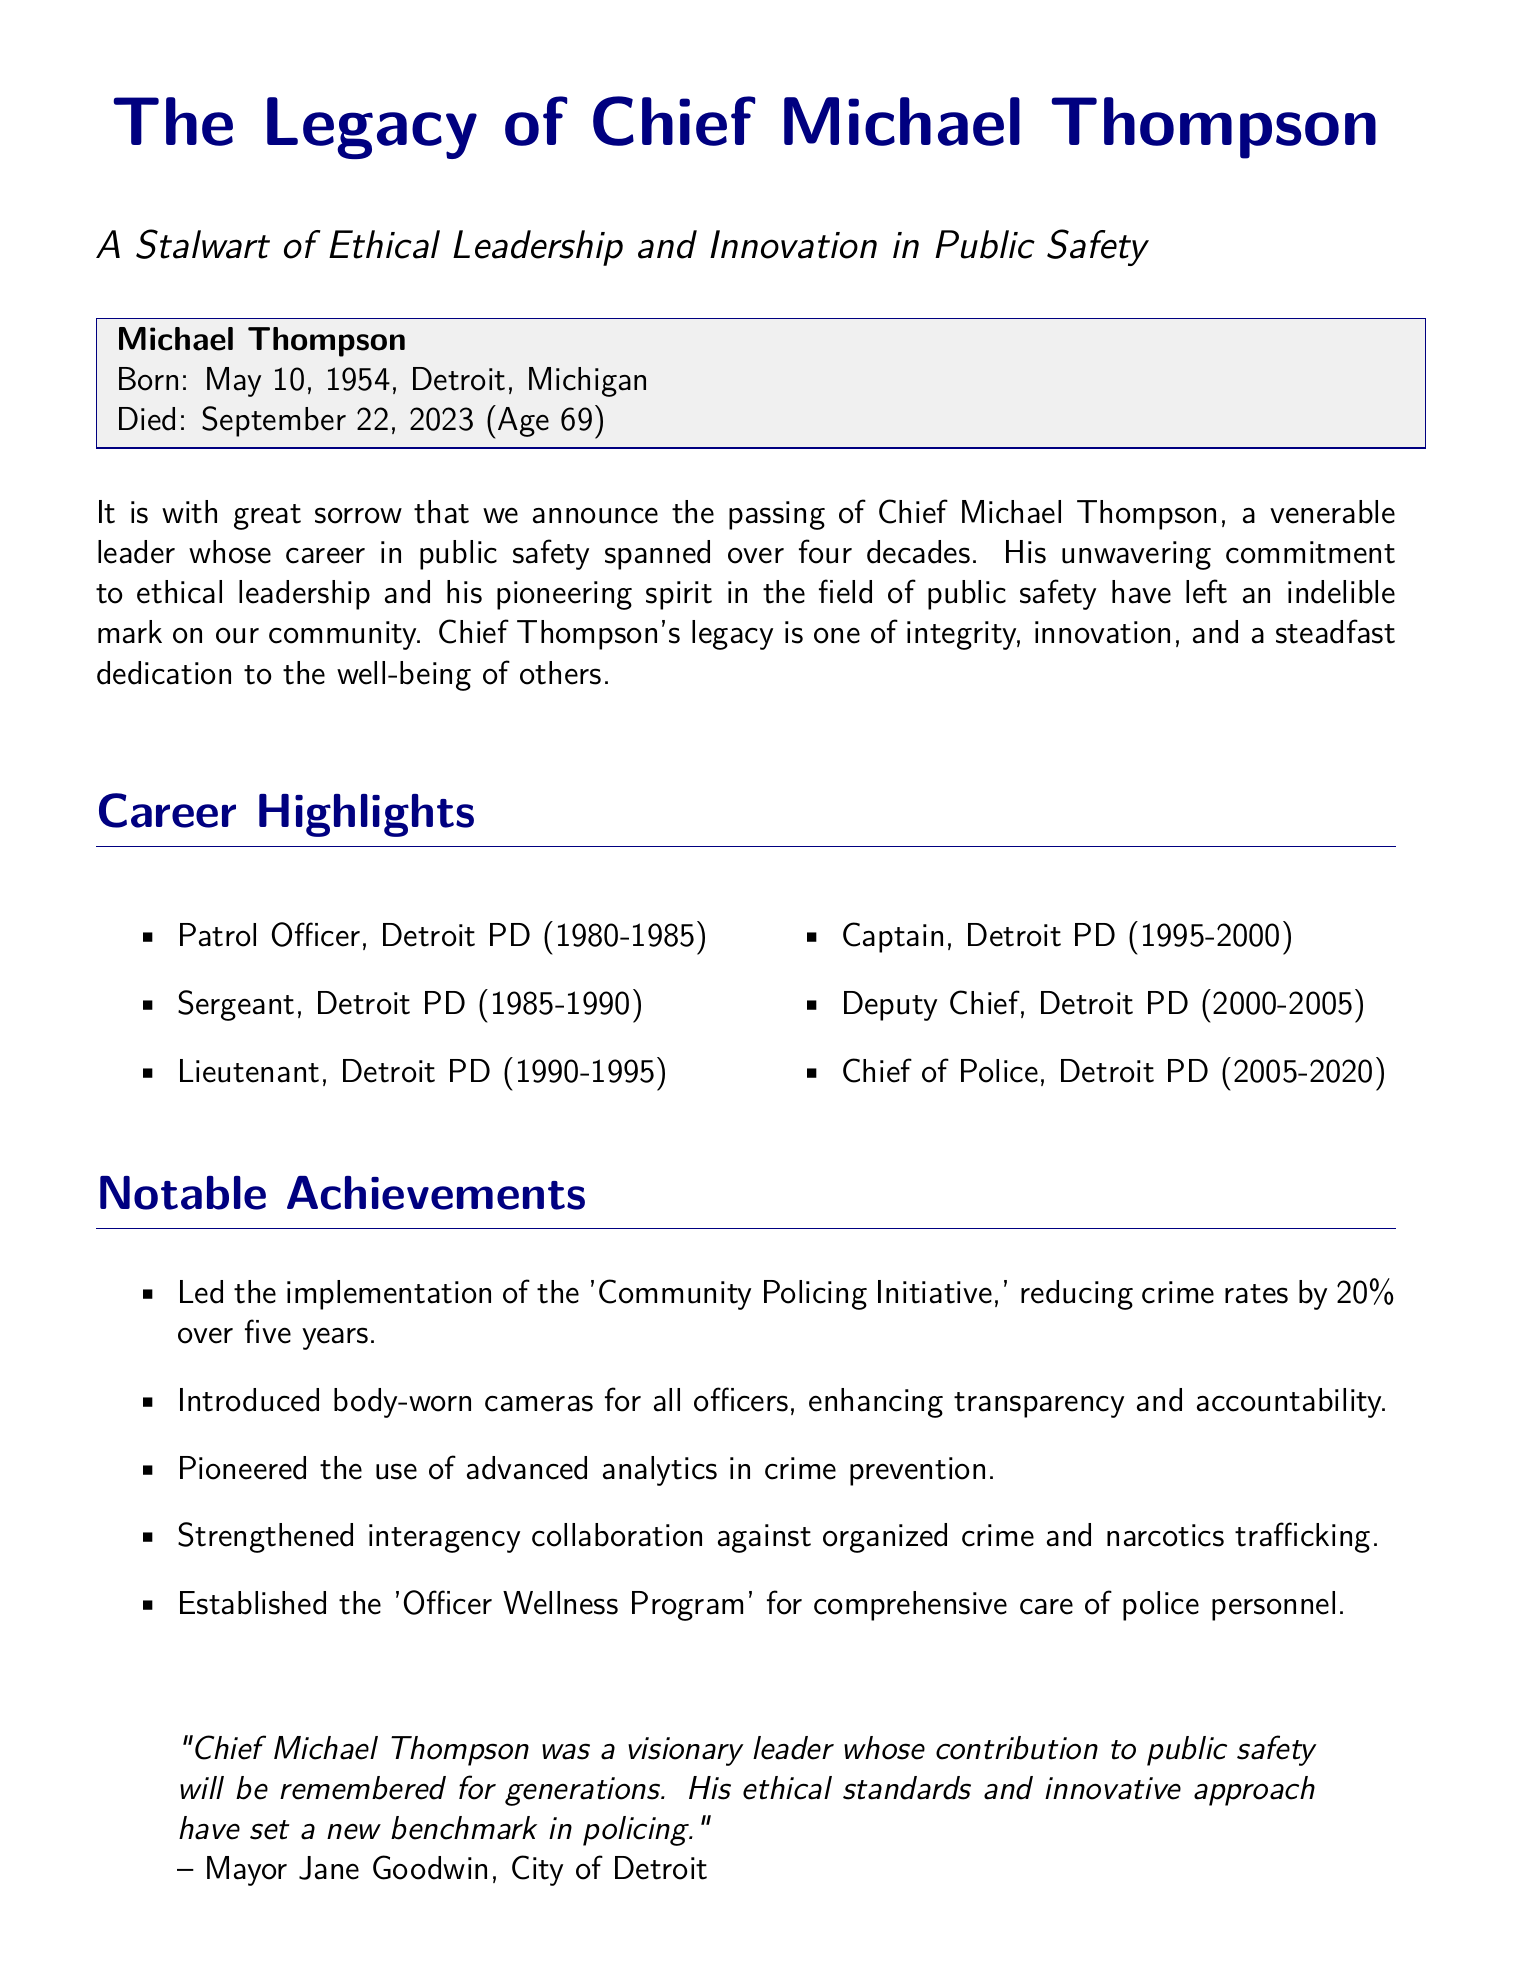What was Chief Michael Thompson's date of birth? Chief Michael Thompson was born on May 10, 1954, as stated in the document.
Answer: May 10, 1954 What position did Chief Thompson hold before becoming Chief of Police? The document lists his career progression, revealing he was Deputy Chief before becoming Chief of Police.
Answer: Deputy Chief How many years did Chief Thompson serve as Chief of Police? He served from 2005 to 2020, a total of 15 years.
Answer: 15 years What initiative did Chief Thompson lead that reduced crime rates? The document specifically mentions the 'Community Policing Initiative' which he led.
Answer: Community Policing Initiative Which technological advancement did Chief Thompson introduce for officers? The introduction of body-worn cameras for officers is highlighted as a notable achievement.
Answer: Body-worn cameras What is the name of Chief Thompson's spouse? The obituary states he is survived by his wife, Margaret.
Answer: Margaret What did Deputy Chief Laura Martinez say about Chief Thompson? She expressed that he was a mentor and a friend.
Answer: Mentor and friend What was the age of Chief Thompson at the time of his death? He passed away at the age of 69, as noted in the document.
Answer: 69 What type of program did Chief Thompson establish for police personnel? The document notes he established the 'Officer Wellness Program.'
Answer: Officer Wellness Program 